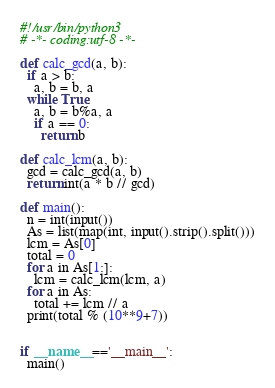<code> <loc_0><loc_0><loc_500><loc_500><_Python_>#!/usr/bin/python3
# -*- coding:utf-8 -*-

def calc_gcd(a, b):
  if a > b:
    a, b = b, a
  while True:
    a, b = b%a, a
    if a == 0:
      return b

def calc_lcm(a, b):
  gcd = calc_gcd(a, b)
  return int(a * b // gcd)

def main():
  n = int(input())
  As = list(map(int, input().strip().split()))
  lcm = As[0]
  total = 0
  for a in As[1:]:
    lcm = calc_lcm(lcm, a)
  for a in As:
    total += lcm // a
  print(total % (10**9+7))


if __name__=='__main__':
  main()</code> 